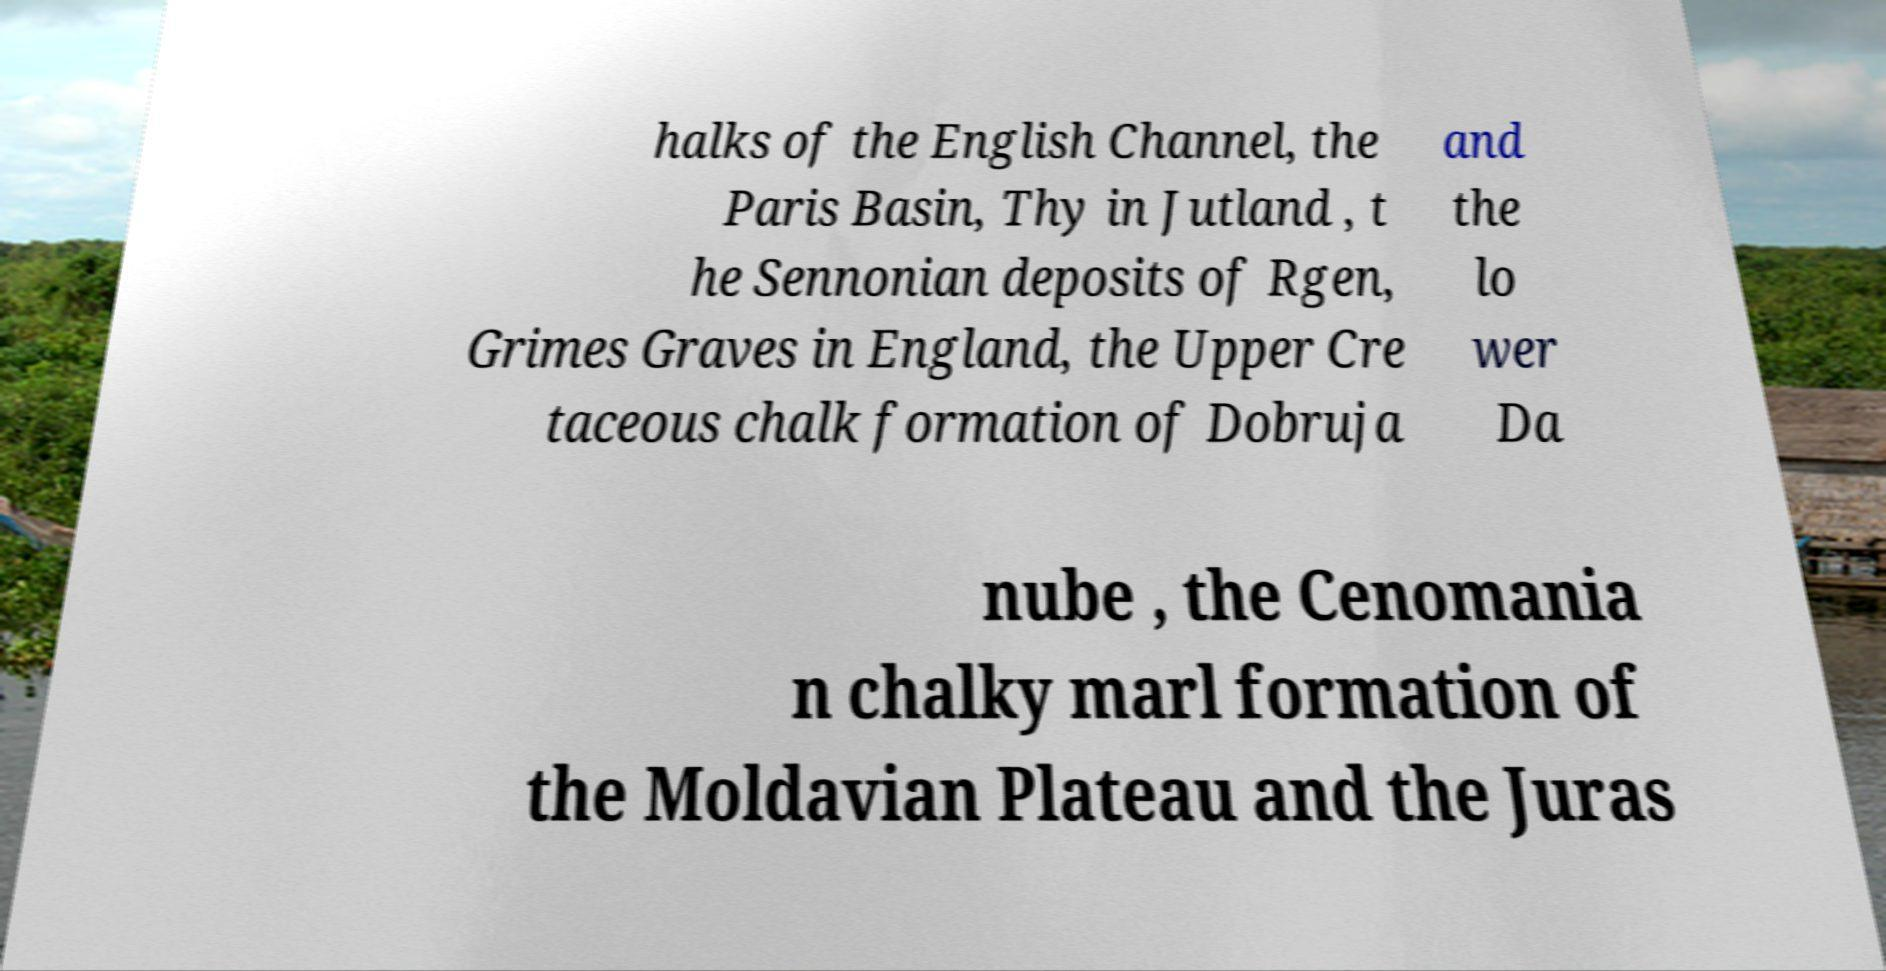Please identify and transcribe the text found in this image. halks of the English Channel, the Paris Basin, Thy in Jutland , t he Sennonian deposits of Rgen, Grimes Graves in England, the Upper Cre taceous chalk formation of Dobruja and the lo wer Da nube , the Cenomania n chalky marl formation of the Moldavian Plateau and the Juras 